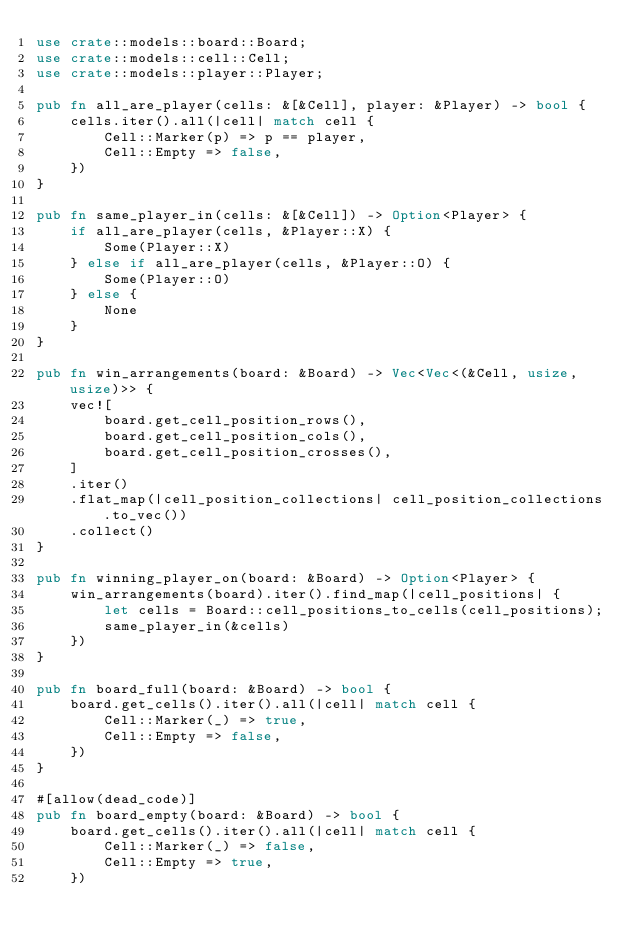Convert code to text. <code><loc_0><loc_0><loc_500><loc_500><_Rust_>use crate::models::board::Board;
use crate::models::cell::Cell;
use crate::models::player::Player;

pub fn all_are_player(cells: &[&Cell], player: &Player) -> bool {
    cells.iter().all(|cell| match cell {
        Cell::Marker(p) => p == player,
        Cell::Empty => false,
    })
}

pub fn same_player_in(cells: &[&Cell]) -> Option<Player> {
    if all_are_player(cells, &Player::X) {
        Some(Player::X)
    } else if all_are_player(cells, &Player::O) {
        Some(Player::O)
    } else {
        None
    }
}

pub fn win_arrangements(board: &Board) -> Vec<Vec<(&Cell, usize, usize)>> {
    vec![
        board.get_cell_position_rows(),
        board.get_cell_position_cols(),
        board.get_cell_position_crosses(),
    ]
    .iter()
    .flat_map(|cell_position_collections| cell_position_collections.to_vec())
    .collect()
}

pub fn winning_player_on(board: &Board) -> Option<Player> {
    win_arrangements(board).iter().find_map(|cell_positions| {
        let cells = Board::cell_positions_to_cells(cell_positions);
        same_player_in(&cells)
    })
}

pub fn board_full(board: &Board) -> bool {
    board.get_cells().iter().all(|cell| match cell {
        Cell::Marker(_) => true,
        Cell::Empty => false,
    })
}

#[allow(dead_code)]
pub fn board_empty(board: &Board) -> bool {
    board.get_cells().iter().all(|cell| match cell {
        Cell::Marker(_) => false,
        Cell::Empty => true,
    })</code> 